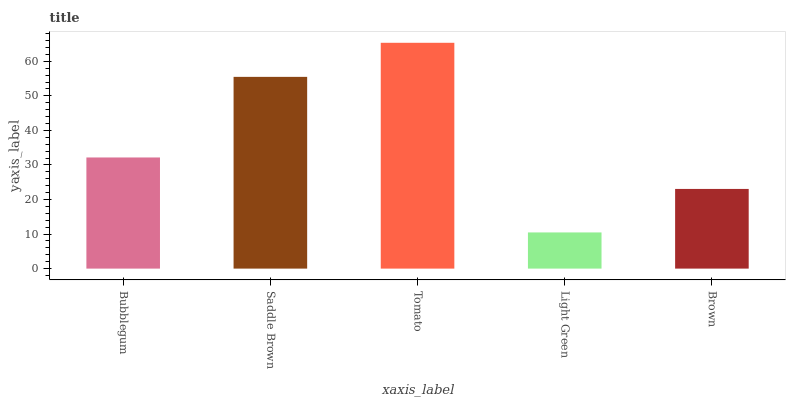Is Light Green the minimum?
Answer yes or no. Yes. Is Tomato the maximum?
Answer yes or no. Yes. Is Saddle Brown the minimum?
Answer yes or no. No. Is Saddle Brown the maximum?
Answer yes or no. No. Is Saddle Brown greater than Bubblegum?
Answer yes or no. Yes. Is Bubblegum less than Saddle Brown?
Answer yes or no. Yes. Is Bubblegum greater than Saddle Brown?
Answer yes or no. No. Is Saddle Brown less than Bubblegum?
Answer yes or no. No. Is Bubblegum the high median?
Answer yes or no. Yes. Is Bubblegum the low median?
Answer yes or no. Yes. Is Brown the high median?
Answer yes or no. No. Is Brown the low median?
Answer yes or no. No. 